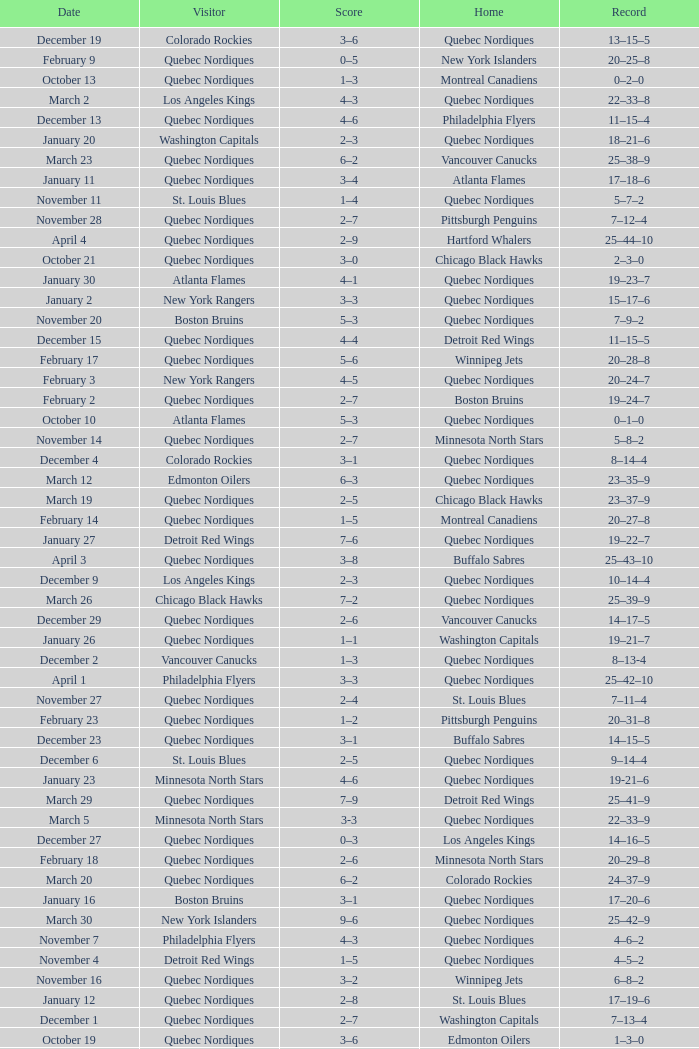Which Record has a Home of edmonton oilers, and a Score of 3–6? 1–3–0. 